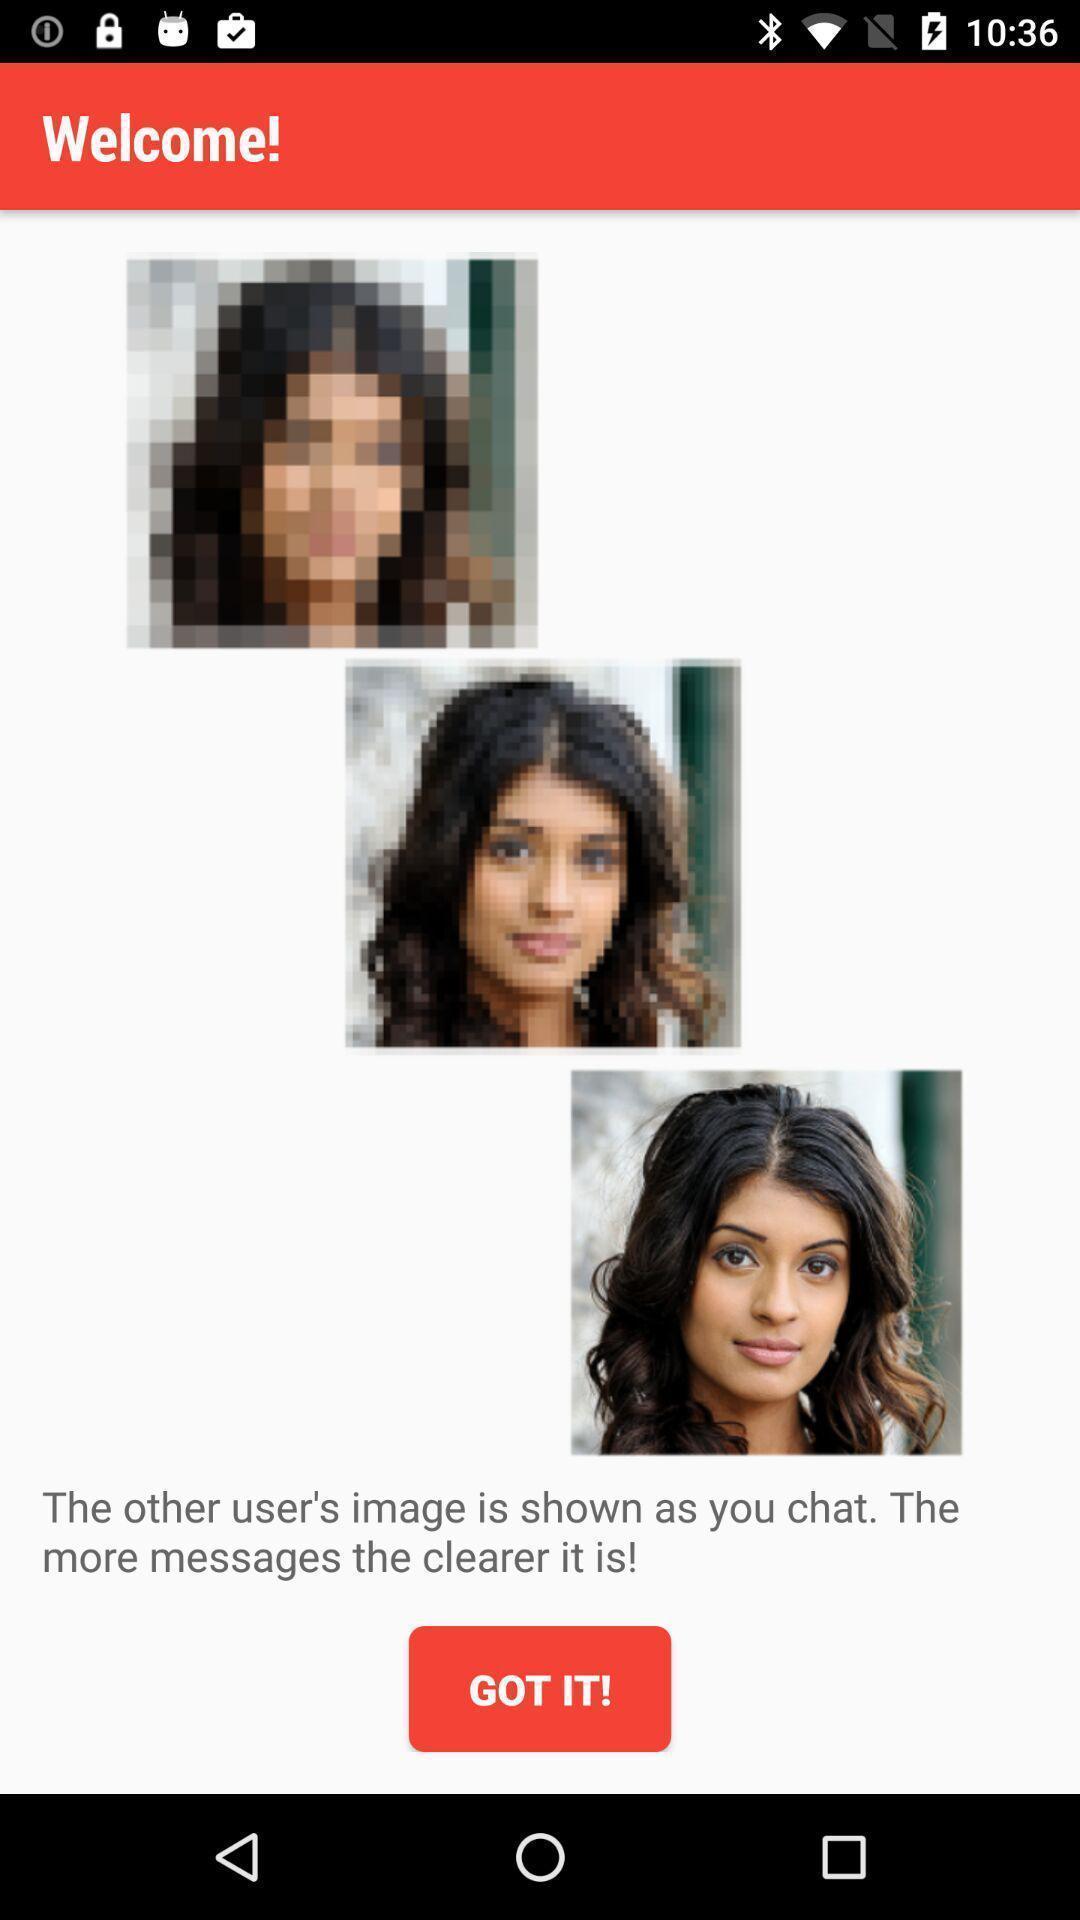What is the overall content of this screenshot? Welcome page to the application with option. 